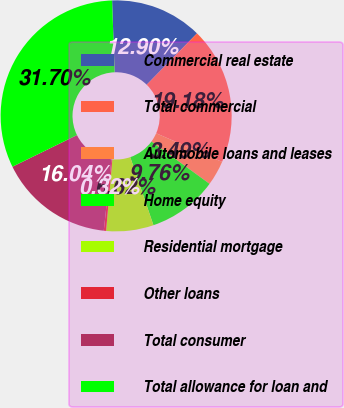Convert chart to OTSL. <chart><loc_0><loc_0><loc_500><loc_500><pie_chart><fcel>Commercial real estate<fcel>Total commercial<fcel>Automobile loans and leases<fcel>Home equity<fcel>Residential mortgage<fcel>Other loans<fcel>Total consumer<fcel>Total allowance for loan and<nl><fcel>12.9%<fcel>19.18%<fcel>3.49%<fcel>9.76%<fcel>6.62%<fcel>0.32%<fcel>16.04%<fcel>31.7%<nl></chart> 